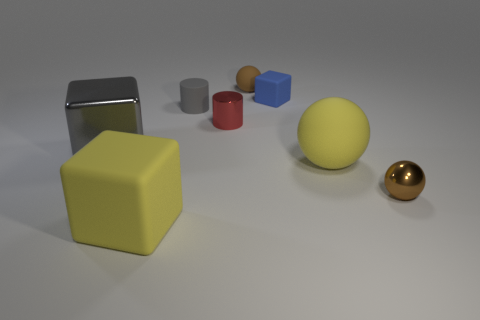How many objects are there and can you describe their colors? There are six objects in the image. Starting from the left, there's a large silver rectangle, a yellow cube, a small gray cylinder, a small red cylinder, a small blue cube, and a yellow sphere at the center. To the far right is a small gold sphere. What do these objects remind you of? The arrangement and variety of objects might remind someone of a simple still life composition used in art to study shapes, colors, and shadows, or a basic assortment of geometric blocks often found in children's educational toys. 